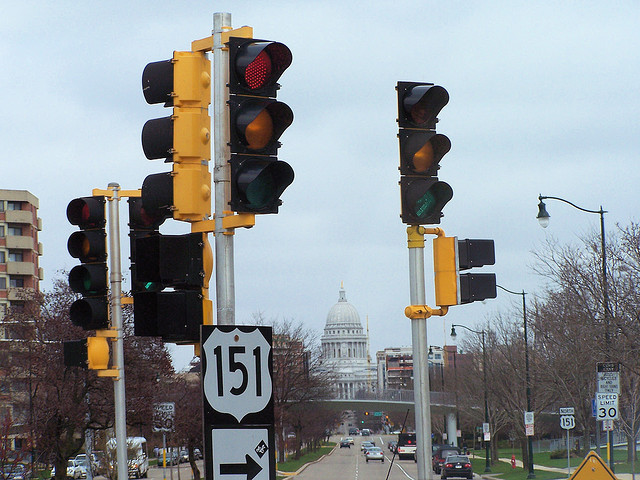Identify the text contained in this image. 151 30 SPECO 151 